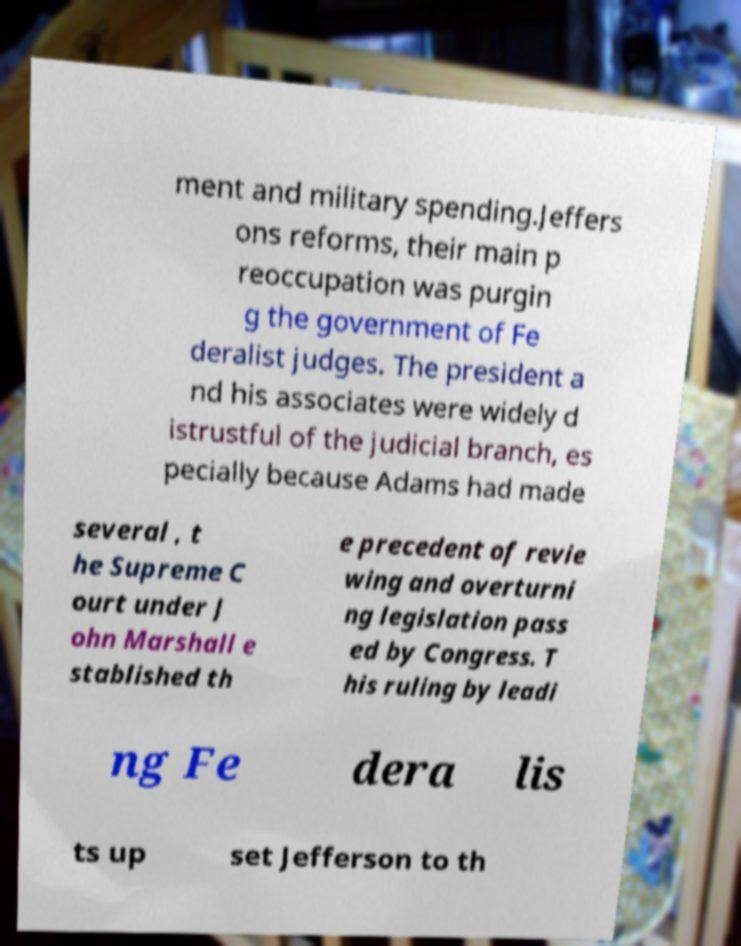For documentation purposes, I need the text within this image transcribed. Could you provide that? ment and military spending.Jeffers ons reforms, their main p reoccupation was purgin g the government of Fe deralist judges. The president a nd his associates were widely d istrustful of the judicial branch, es pecially because Adams had made several , t he Supreme C ourt under J ohn Marshall e stablished th e precedent of revie wing and overturni ng legislation pass ed by Congress. T his ruling by leadi ng Fe dera lis ts up set Jefferson to th 